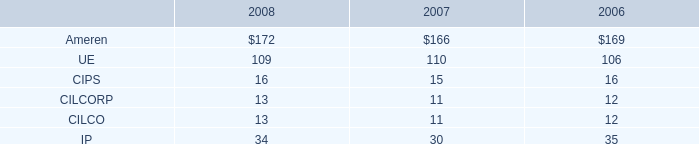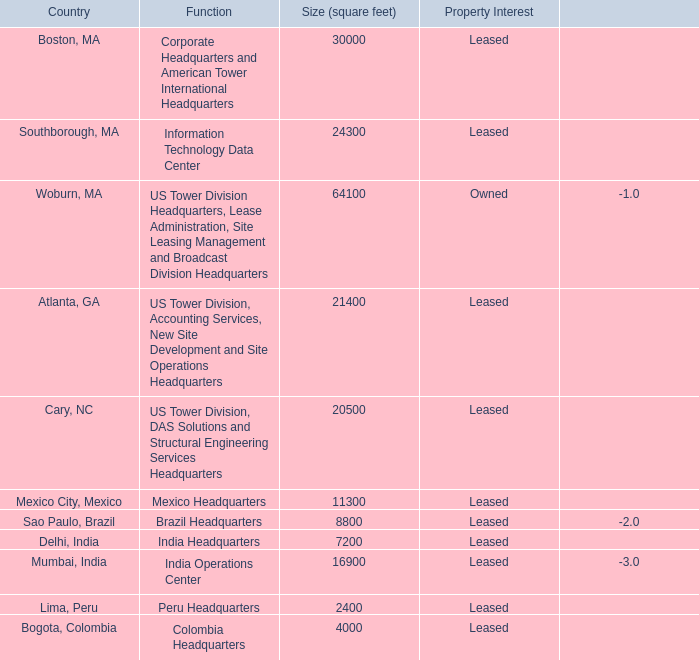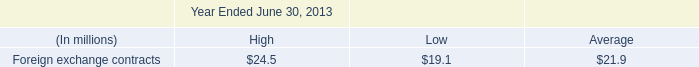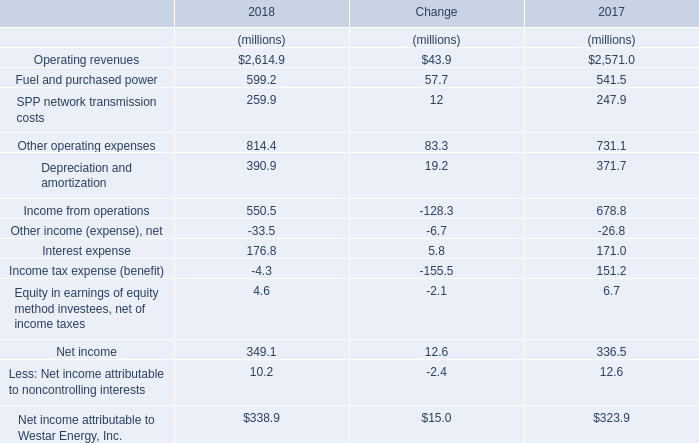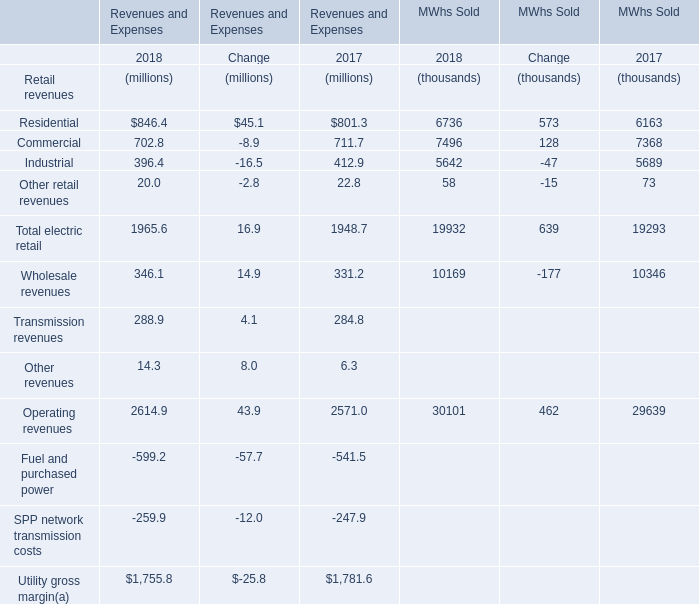What was the sum of Revenues and Expenses without those Residential smaller than 1000, in 2018? (in million) 
Computations: (1755.8 + 846.4)
Answer: 2602.2. 